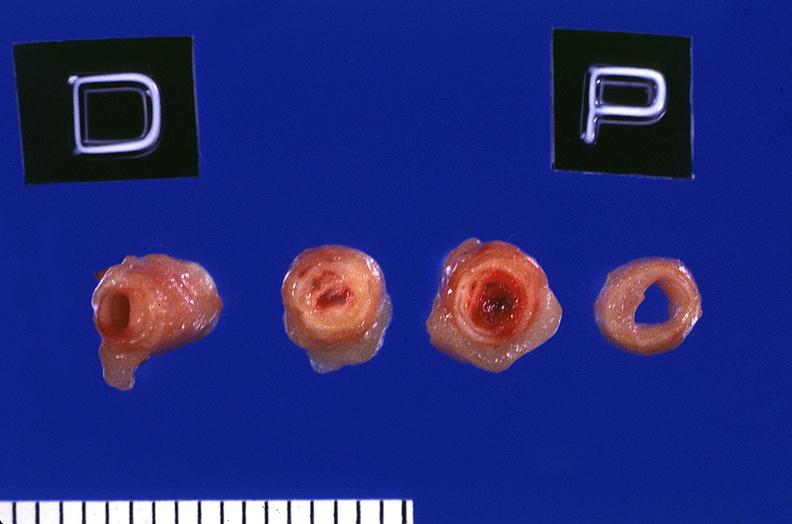s vasculature present?
Answer the question using a single word or phrase. Yes 